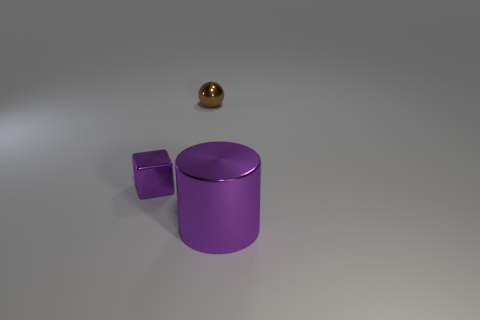Subtract all blocks. How many objects are left? 2 Add 3 large metal cylinders. How many objects exist? 6 Add 2 large purple metallic things. How many large purple metallic things exist? 3 Subtract 0 blue cylinders. How many objects are left? 3 Subtract 1 blocks. How many blocks are left? 0 Subtract all brown metallic objects. Subtract all small red matte objects. How many objects are left? 2 Add 2 purple metallic cylinders. How many purple metallic cylinders are left? 3 